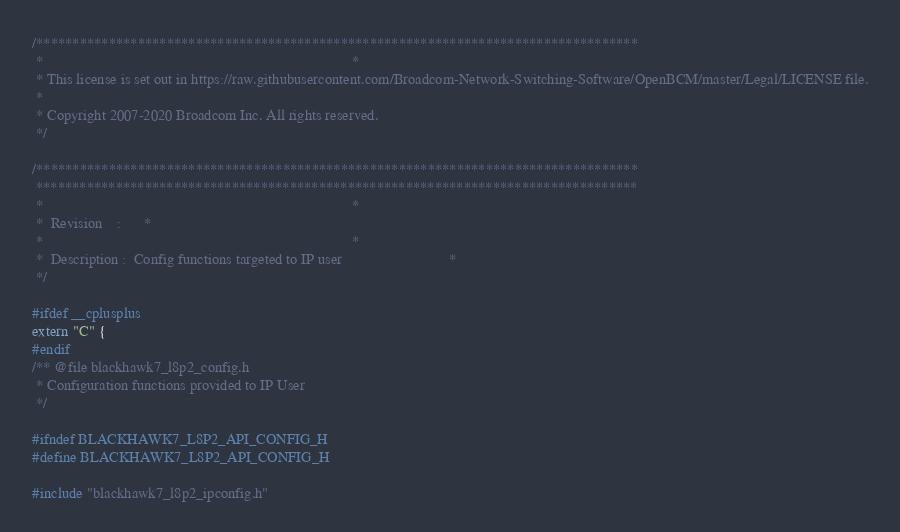<code> <loc_0><loc_0><loc_500><loc_500><_C_>/***********************************************************************************
 *                                                                                 *
 * This license is set out in https://raw.githubusercontent.com/Broadcom-Network-Switching-Software/OpenBCM/master/Legal/LICENSE file.
 * 
 * Copyright 2007-2020 Broadcom Inc. All rights reserved.
 */

/***********************************************************************************
 ***********************************************************************************
 *                                                                                 *
 *  Revision    :      *
 *                                                                                 *
 *  Description :  Config functions targeted to IP user                            *
 */

#ifdef __cplusplus
extern "C" {
#endif
/** @file blackhawk7_l8p2_config.h
 * Configuration functions provided to IP User
 */

#ifndef BLACKHAWK7_L8P2_API_CONFIG_H
#define BLACKHAWK7_L8P2_API_CONFIG_H

#include "blackhawk7_l8p2_ipconfig.h"</code> 